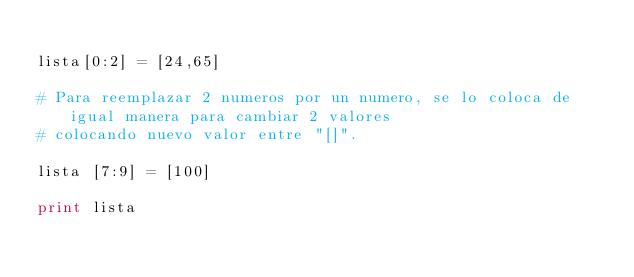Convert code to text. <code><loc_0><loc_0><loc_500><loc_500><_Python_>
lista[0:2] = [24,65]

# Para reemplazar 2 numeros por un numero, se lo coloca de igual manera para cambiar 2 valores
# colocando nuevo valor entre "[]".

lista [7:9] = [100]

print lista</code> 